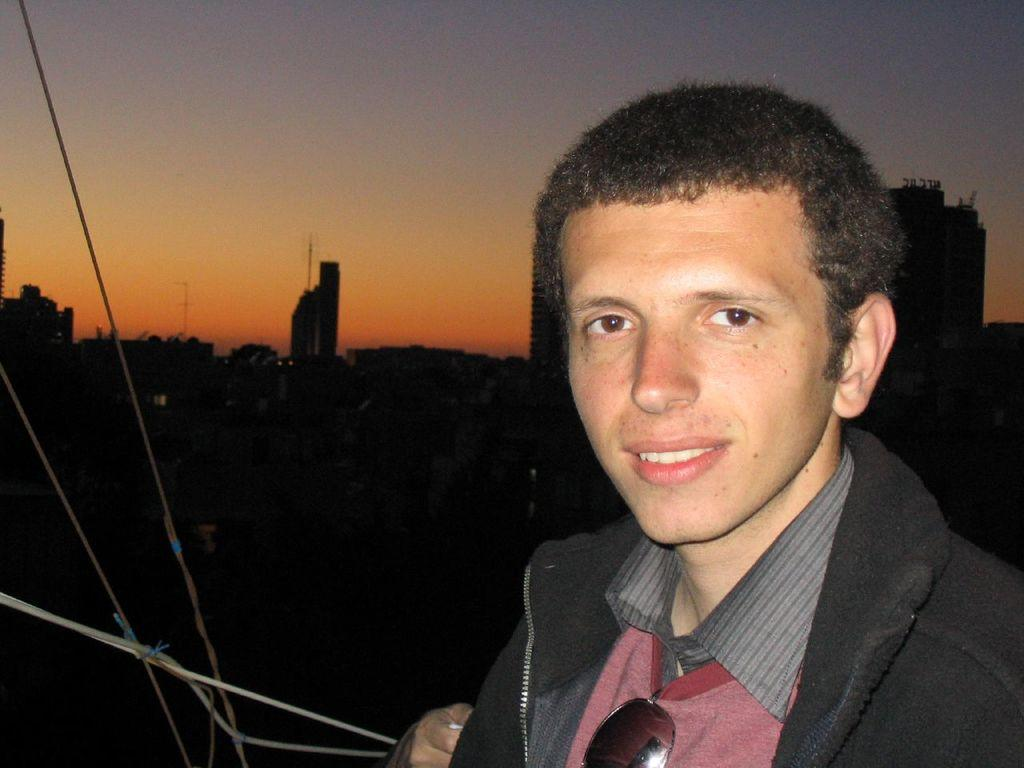What is the main subject in the foreground of the image? There is a man in the foreground of the image. What is the man wearing? The man is wearing a black dress. What is the man's facial expression in the image? The man is smiling. What can be seen in the background of the image? There is a city and the sky visible in the background of the image. What type of zinc is present in the image? There is no zinc present in the image. What action is the man performing in the image? The provided facts do not mention any specific action the man is performing; he is simply standing and smiling. 